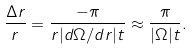<formula> <loc_0><loc_0><loc_500><loc_500>\frac { \Delta r } { r } = \frac { - \pi } { r | d \Omega / d r | t } \approx \frac { \pi } { | \Omega | t } .</formula> 